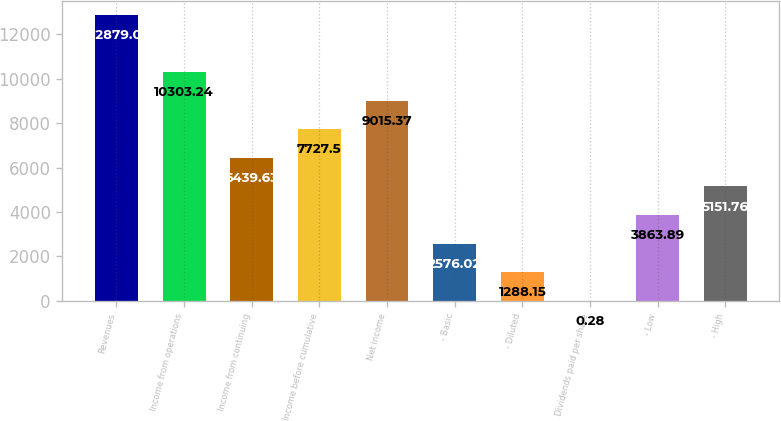<chart> <loc_0><loc_0><loc_500><loc_500><bar_chart><fcel>Revenues<fcel>Income from operations<fcel>Income from continuing<fcel>Income before cumulative<fcel>Net income<fcel>- Basic<fcel>- Diluted<fcel>Dividends paid per share<fcel>- Low<fcel>- High<nl><fcel>12879<fcel>10303.2<fcel>6439.63<fcel>7727.5<fcel>9015.37<fcel>2576.02<fcel>1288.15<fcel>0.28<fcel>3863.89<fcel>5151.76<nl></chart> 